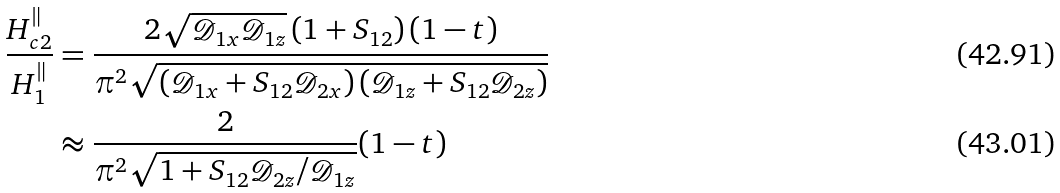Convert formula to latex. <formula><loc_0><loc_0><loc_500><loc_500>\frac { H _ { c 2 } ^ { \| } } { H _ { 1 } ^ { \| } } & = \frac { 2 \sqrt { \mathcal { D } _ { 1 x } \mathcal { D } _ { 1 z } } \left ( 1 + S _ { 1 2 } \right ) ( 1 - t ) } { \pi ^ { 2 } \sqrt { \left ( \mathcal { D } _ { 1 x } + S _ { 1 2 } \mathcal { D } _ { 2 x } \right ) \left ( \mathcal { D } _ { 1 z } + S _ { 1 2 } \mathcal { D } _ { 2 z } \right ) } } \\ & \approx \frac { 2 } { \pi ^ { 2 } \sqrt { 1 + S _ { 1 2 } \mathcal { D } _ { 2 z } / \mathcal { D } _ { 1 z } } } ( 1 - t )</formula> 